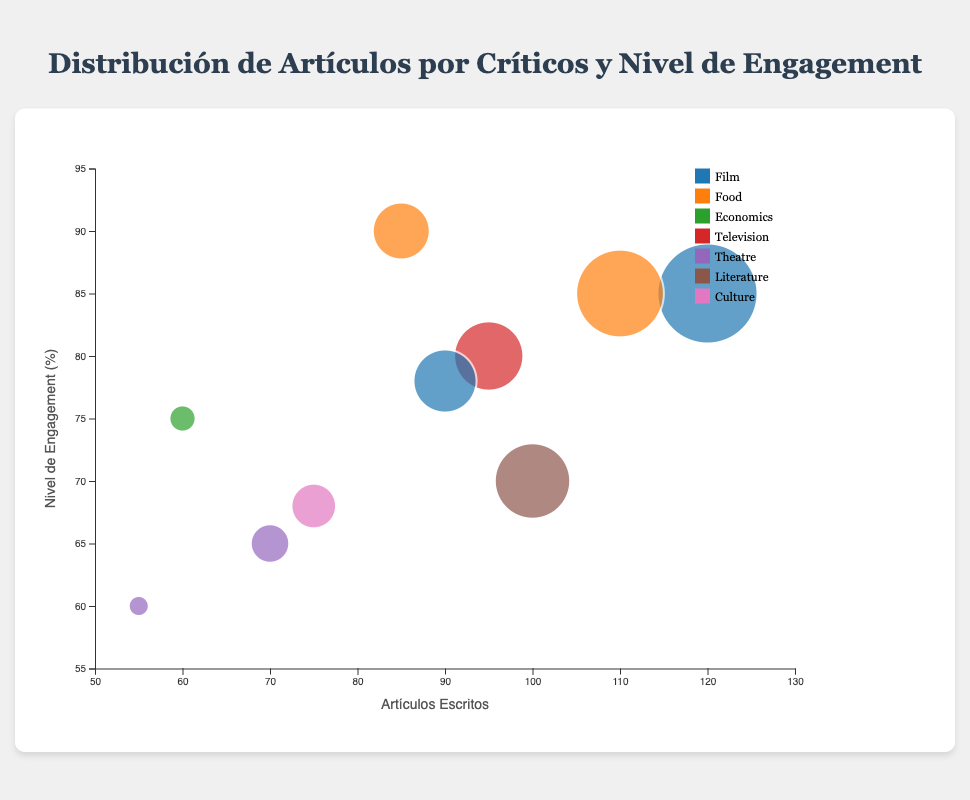¿Cuál es la crítica con el mayor número de artículos escritos? Observando las burbujas y el eje x que representa 'Artículos Escritos', la burbuja más a la derecha representa a A.O. Scott con 120 artículos.
Answer: A.O. Scott ¿Cuántos críticos han escrito más de 100 artículos? Contando las burbujas cuyo valor en el eje x es mayor a 100, identificamos a A.O. Scott y Pete Wells, lo cual suma dos críticos.
Answer: 2 ¿Qué crítico en el área de "Cultura" tiene un nivel de engagement del 68%? Identificando el área de "Cultura" usando la leyenda visual y luego observando la posición de la burbuja en el eje y (68%), el crítico es David Brooks.
Answer: David Brooks ¿Cuál es la diferencia en el nivel de engagement entre Hilton Als y John Lahr? El nivel de engagement de Hilton Als es 65% y de John Lahr es 60%. La diferencia es 65% - 60% = 5%.
Answer: 5% ¿Cuál es el crítico con mayor engagement en el área de "Food"? Observando las burbujas codificadas por color para el área "Food" y comparando su posición en el eje y, Jonathan Gold tiene un engagement del 90%, el mayor de su área.
Answer: Jonathan Gold ¿Qué crítico tiene el menor número de artículos escritos y cuál es su nivel de engagement? Mirando las burbujas más a la izquierda en el eje x, John Lahr tiene el menor número de artículos (55) y su nivel de engagement es 60%.
Answer: John Lahr, 60% En promedio, ¿cuánto engagement tienen los críticos del área de "Film"? Los críticos del área "Film" son A.O. Scott y Wesley Morris con engagements de 85% y 78%. El promedio es (85 + 78) / 2 = 81.5%.
Answer: 81.5% Entre A.O. Scott y Michiko Kakutani, ¿quién escribió más artículos y cómo se compara su nivel de engagement? A.O. Scott escribió 120 artículos y tiene un engagement de 85%, mientras que Michiko Kakutani escribió 100 artículos con un engagement de 70%. Ambos tienen diferentes niveles de engagement, siendo A.O. Scott más alto.
Answer: A.O. Scott escribió más artículos y tiene un mayor engagement ¿Cuántos artículos ha escrito el crítico con el mayor nivel de engagement general y cuál es su área de enfoque? Jonathan Gold tiene el mayor engagement general de 90%, y ha escrito 85 artículos en el área de "Food".
Answer: 85 artículos, Food ¿Cuáles son los niveles de engagement para los críticos en el área de "Theatre"? Observando las burbujas correspondientes al área "Theatre" en la leyenda, los críticos son Hilton Als (65%) y John Lahr (60%).
Answer: 65% y 60% 